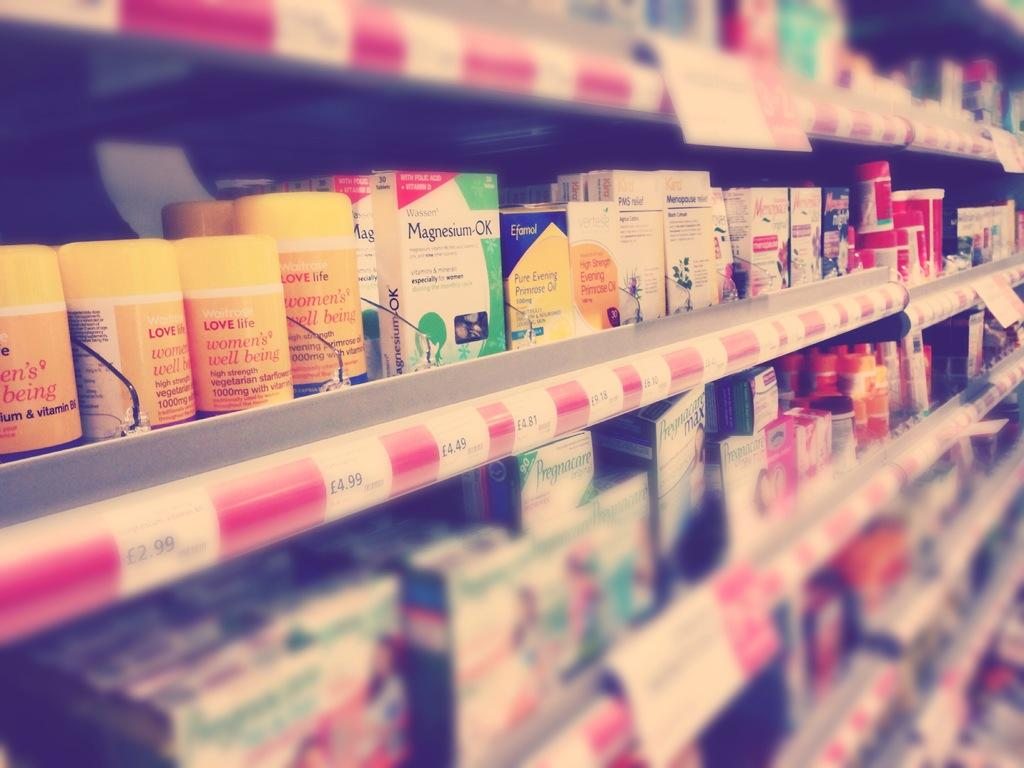<image>
Give a short and clear explanation of the subsequent image. On a pharmacy shelf, one box reads "Magnesium-OK." 